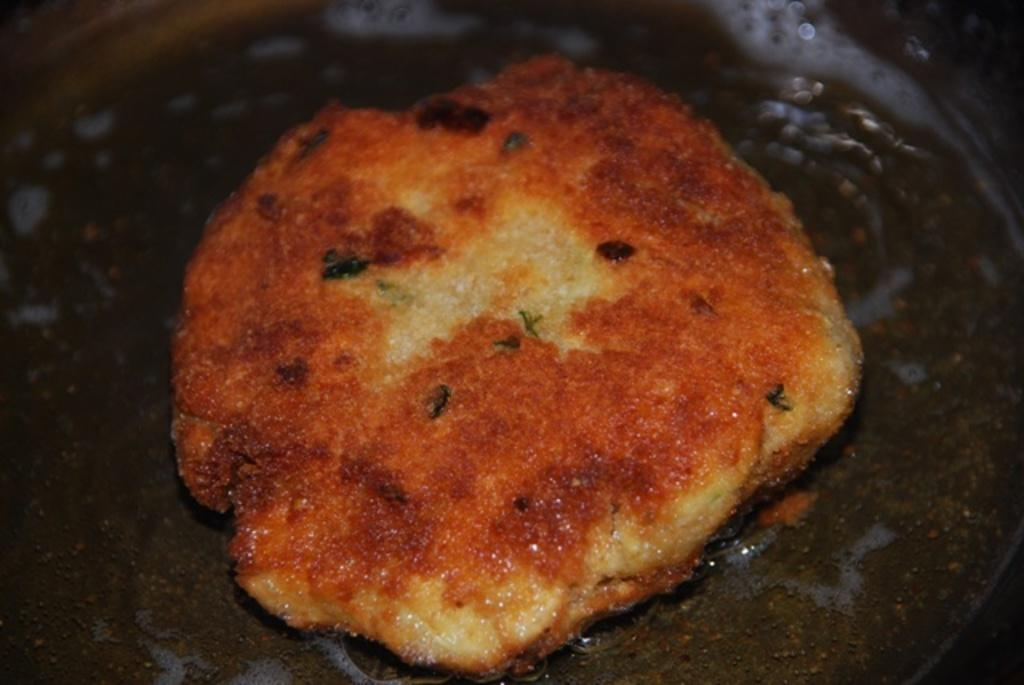What is the main subject of the image? There is a food item in the image. How is the food item being prepared or served? The food item is in a pan. What type of whip is being used to prepare the food item in the image? There is no whip present in the image; it only shows a food item in a pan. 